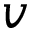Convert formula to latex. <formula><loc_0><loc_0><loc_500><loc_500>v</formula> 